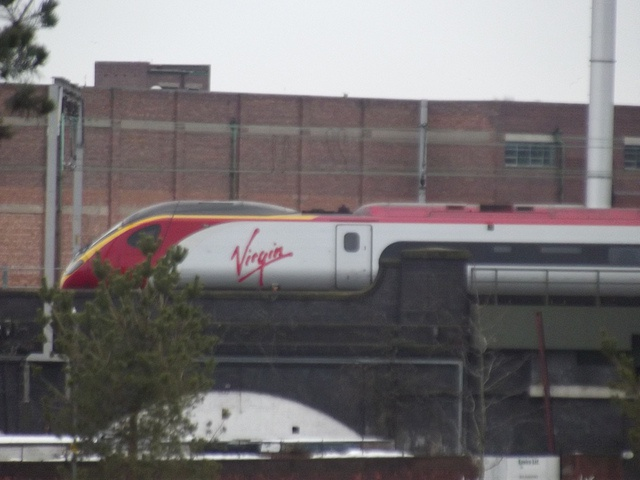Describe the objects in this image and their specific colors. I can see a train in black, gray, darkgray, brown, and lightgray tones in this image. 